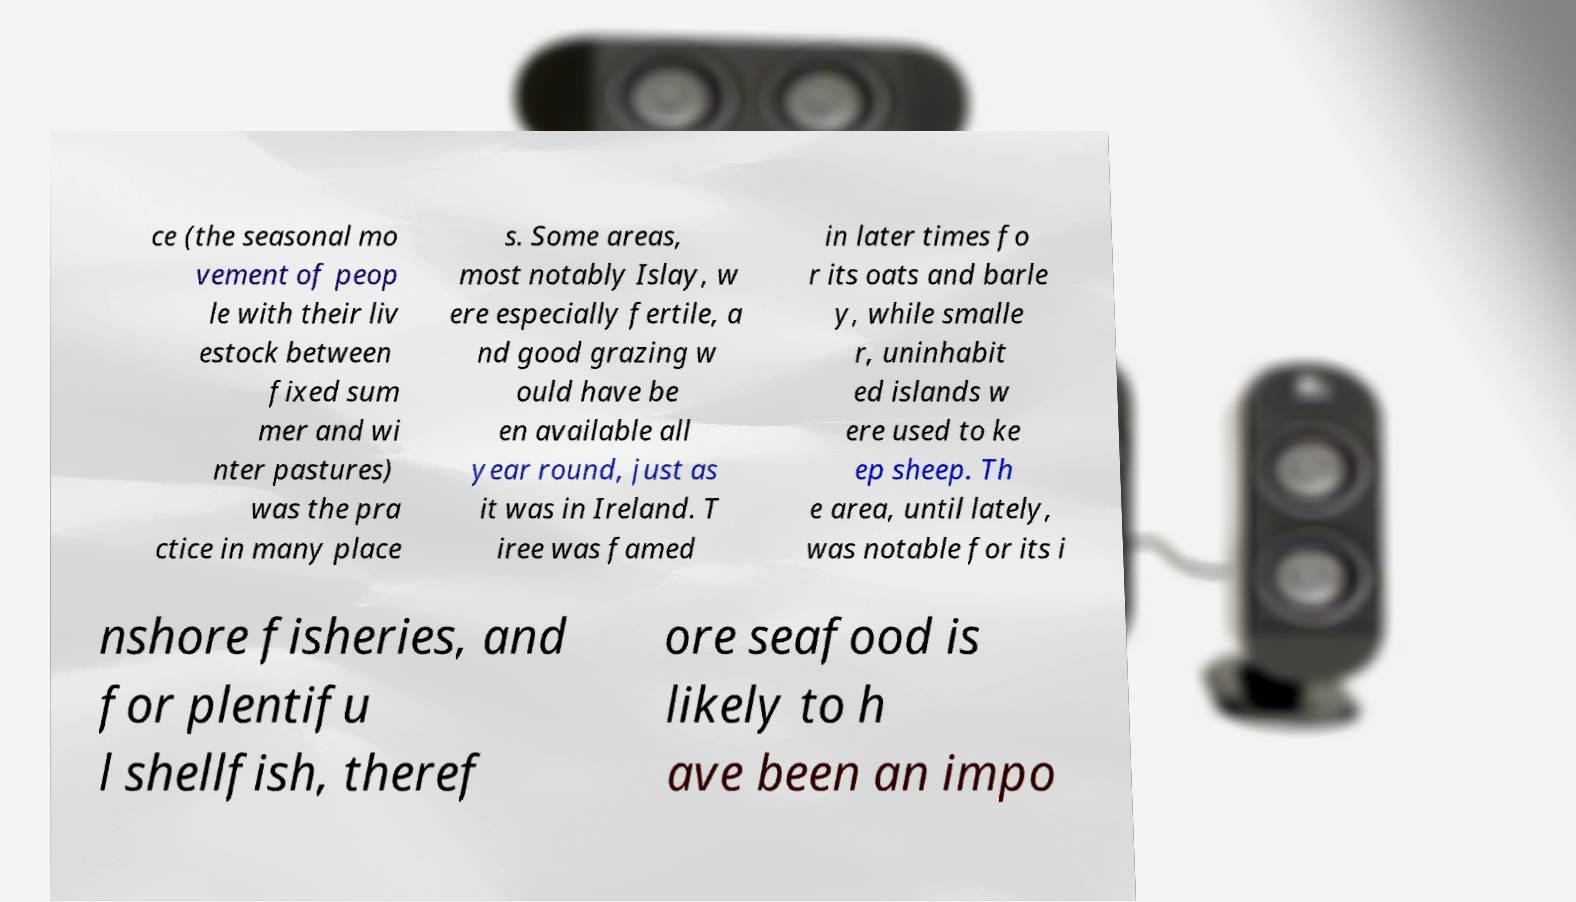I need the written content from this picture converted into text. Can you do that? ce (the seasonal mo vement of peop le with their liv estock between fixed sum mer and wi nter pastures) was the pra ctice in many place s. Some areas, most notably Islay, w ere especially fertile, a nd good grazing w ould have be en available all year round, just as it was in Ireland. T iree was famed in later times fo r its oats and barle y, while smalle r, uninhabit ed islands w ere used to ke ep sheep. Th e area, until lately, was notable for its i nshore fisheries, and for plentifu l shellfish, theref ore seafood is likely to h ave been an impo 